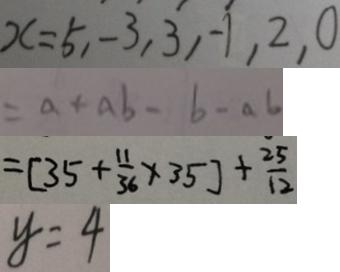Convert formula to latex. <formula><loc_0><loc_0><loc_500><loc_500>x = 5 , - 3 , 3 , - 1 , 2 , 0 
 = a + a b - b - a b 
 = [ 3 5 + \frac { 1 1 } { 3 6 } \times 3 5 ] + \frac { 2 5 } { 1 2 } 
 y = 4</formula> 